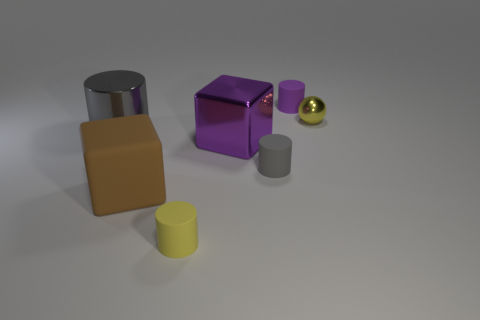Add 1 cyan rubber cubes. How many objects exist? 8 Subtract all balls. How many objects are left? 6 Add 1 yellow metallic objects. How many yellow metallic objects exist? 2 Subtract 0 gray balls. How many objects are left? 7 Subtract all large rubber blocks. Subtract all big matte objects. How many objects are left? 5 Add 3 matte cubes. How many matte cubes are left? 4 